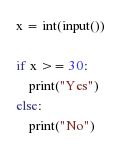Convert code to text. <code><loc_0><loc_0><loc_500><loc_500><_Python_>x = int(input())

if x >= 30:
    print("Yes")
else:
    print("No")</code> 